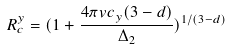<formula> <loc_0><loc_0><loc_500><loc_500>R _ { c } ^ { y } = ( 1 + \frac { 4 \pi v c _ { y } ( 3 - d ) } { \Delta _ { 2 } } ) ^ { 1 / ( 3 - d ) }</formula> 